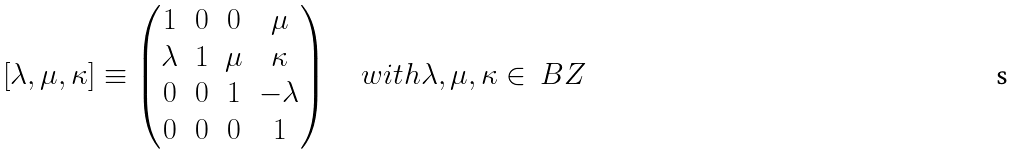Convert formula to latex. <formula><loc_0><loc_0><loc_500><loc_500>[ \lambda , \mu , \kappa ] \equiv \begin{pmatrix} 1 & 0 & 0 & \mu \\ \lambda & 1 & \mu & \kappa \\ 0 & 0 & 1 & - \lambda \\ 0 & 0 & 0 & 1 \end{pmatrix} \quad w i t h \lambda , \mu , \kappa \in \ B Z</formula> 